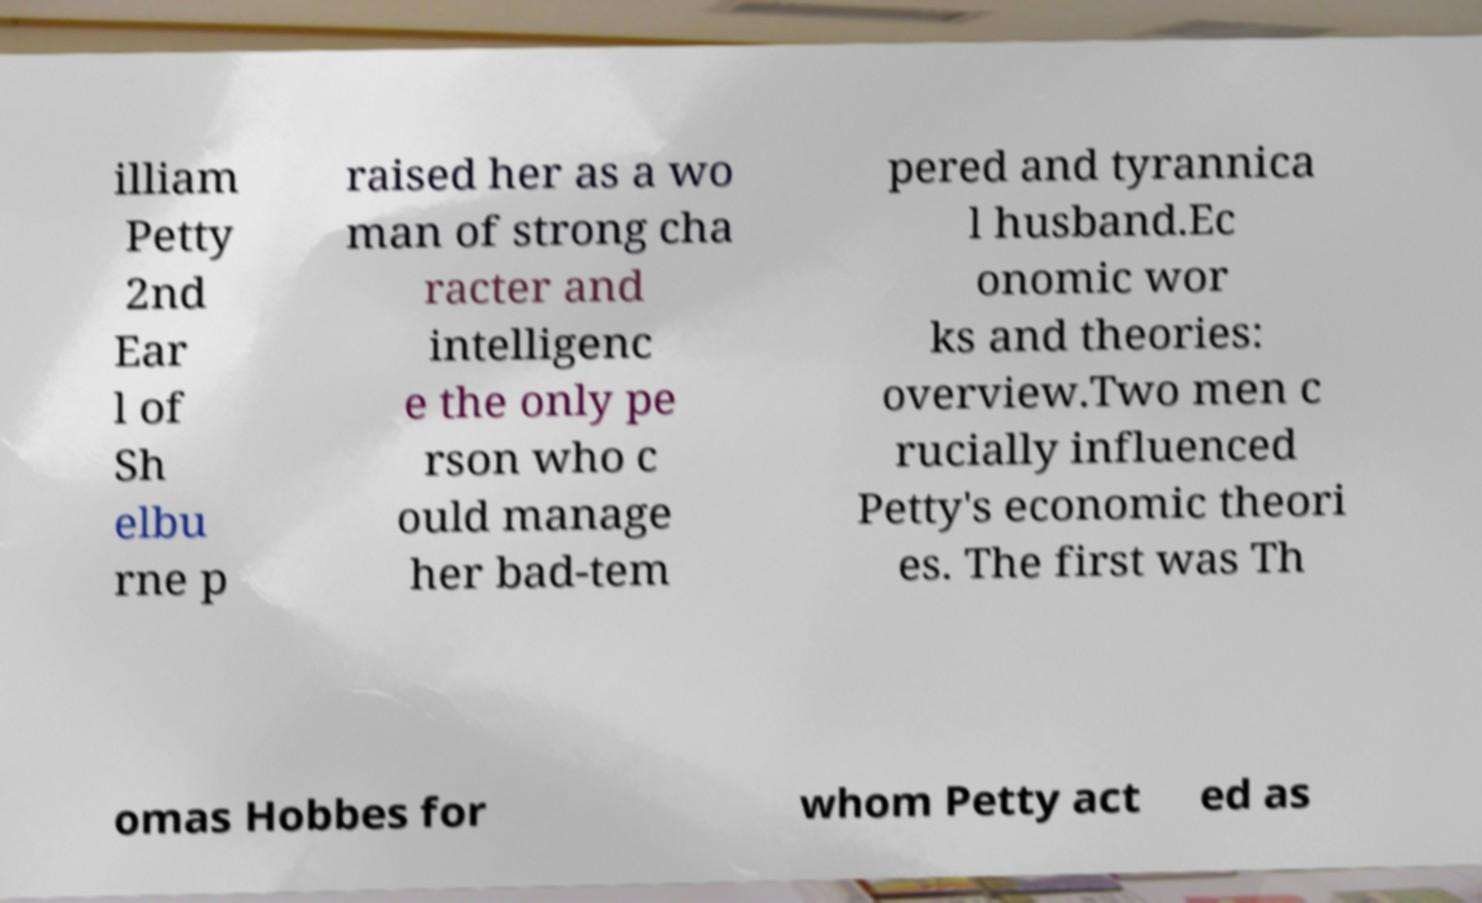There's text embedded in this image that I need extracted. Can you transcribe it verbatim? illiam Petty 2nd Ear l of Sh elbu rne p raised her as a wo man of strong cha racter and intelligenc e the only pe rson who c ould manage her bad-tem pered and tyrannica l husband.Ec onomic wor ks and theories: overview.Two men c rucially influenced Petty's economic theori es. The first was Th omas Hobbes for whom Petty act ed as 